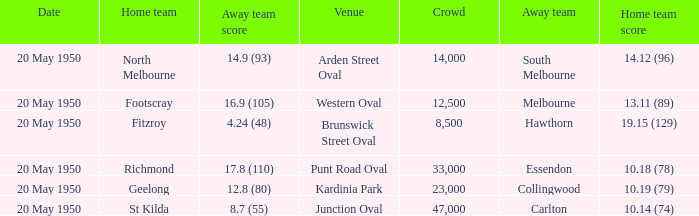What was the score for the away team that played against Richmond and has a crowd over 12,500? 17.8 (110). 